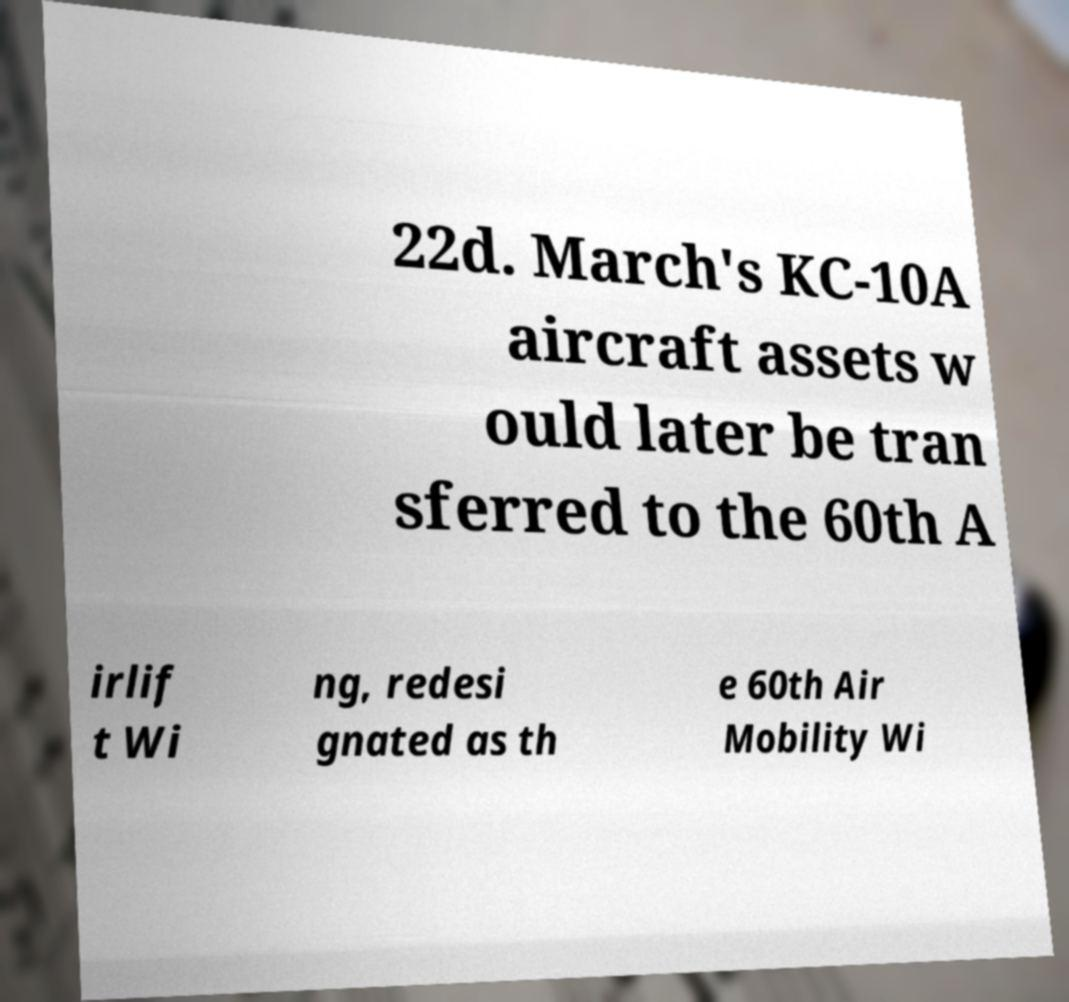Please identify and transcribe the text found in this image. 22d. March's KC-10A aircraft assets w ould later be tran sferred to the 60th A irlif t Wi ng, redesi gnated as th e 60th Air Mobility Wi 